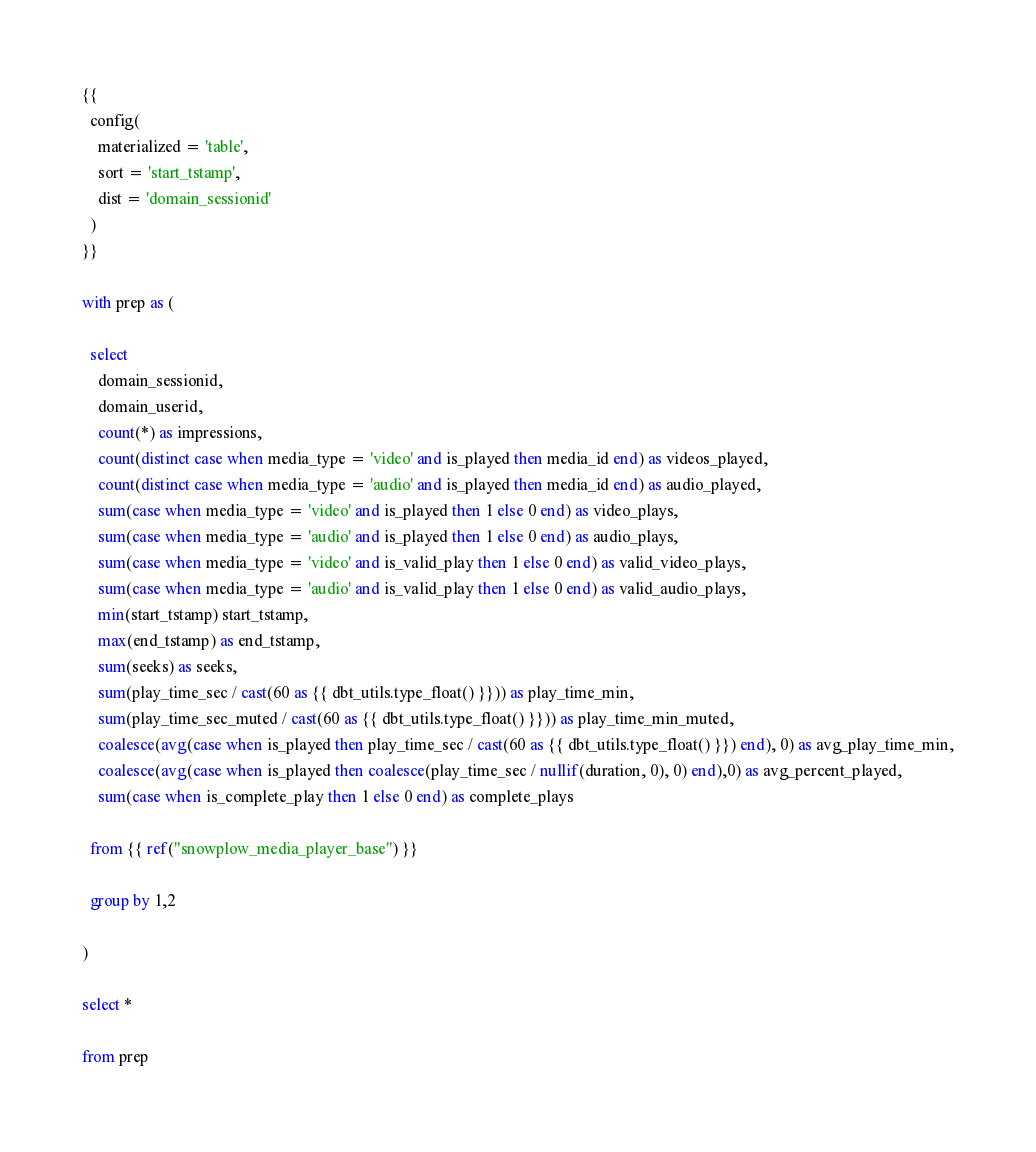<code> <loc_0><loc_0><loc_500><loc_500><_SQL_>{{
  config(
    materialized = 'table',
    sort = 'start_tstamp',
    dist = 'domain_sessionid'
  )
}}

with prep as (

  select
    domain_sessionid,
    domain_userid,
    count(*) as impressions,
    count(distinct case when media_type = 'video' and is_played then media_id end) as videos_played,
    count(distinct case when media_type = 'audio' and is_played then media_id end) as audio_played,
    sum(case when media_type = 'video' and is_played then 1 else 0 end) as video_plays,
    sum(case when media_type = 'audio' and is_played then 1 else 0 end) as audio_plays,
    sum(case when media_type = 'video' and is_valid_play then 1 else 0 end) as valid_video_plays,
    sum(case when media_type = 'audio' and is_valid_play then 1 else 0 end) as valid_audio_plays,
    min(start_tstamp) start_tstamp,
    max(end_tstamp) as end_tstamp,
    sum(seeks) as seeks,
    sum(play_time_sec / cast(60 as {{ dbt_utils.type_float() }})) as play_time_min,
    sum(play_time_sec_muted / cast(60 as {{ dbt_utils.type_float() }})) as play_time_min_muted,
    coalesce(avg(case when is_played then play_time_sec / cast(60 as {{ dbt_utils.type_float() }}) end), 0) as avg_play_time_min,
    coalesce(avg(case when is_played then coalesce(play_time_sec / nullif(duration, 0), 0) end),0) as avg_percent_played,
    sum(case when is_complete_play then 1 else 0 end) as complete_plays

  from {{ ref("snowplow_media_player_base") }}

  group by 1,2

)

select *

from prep
</code> 